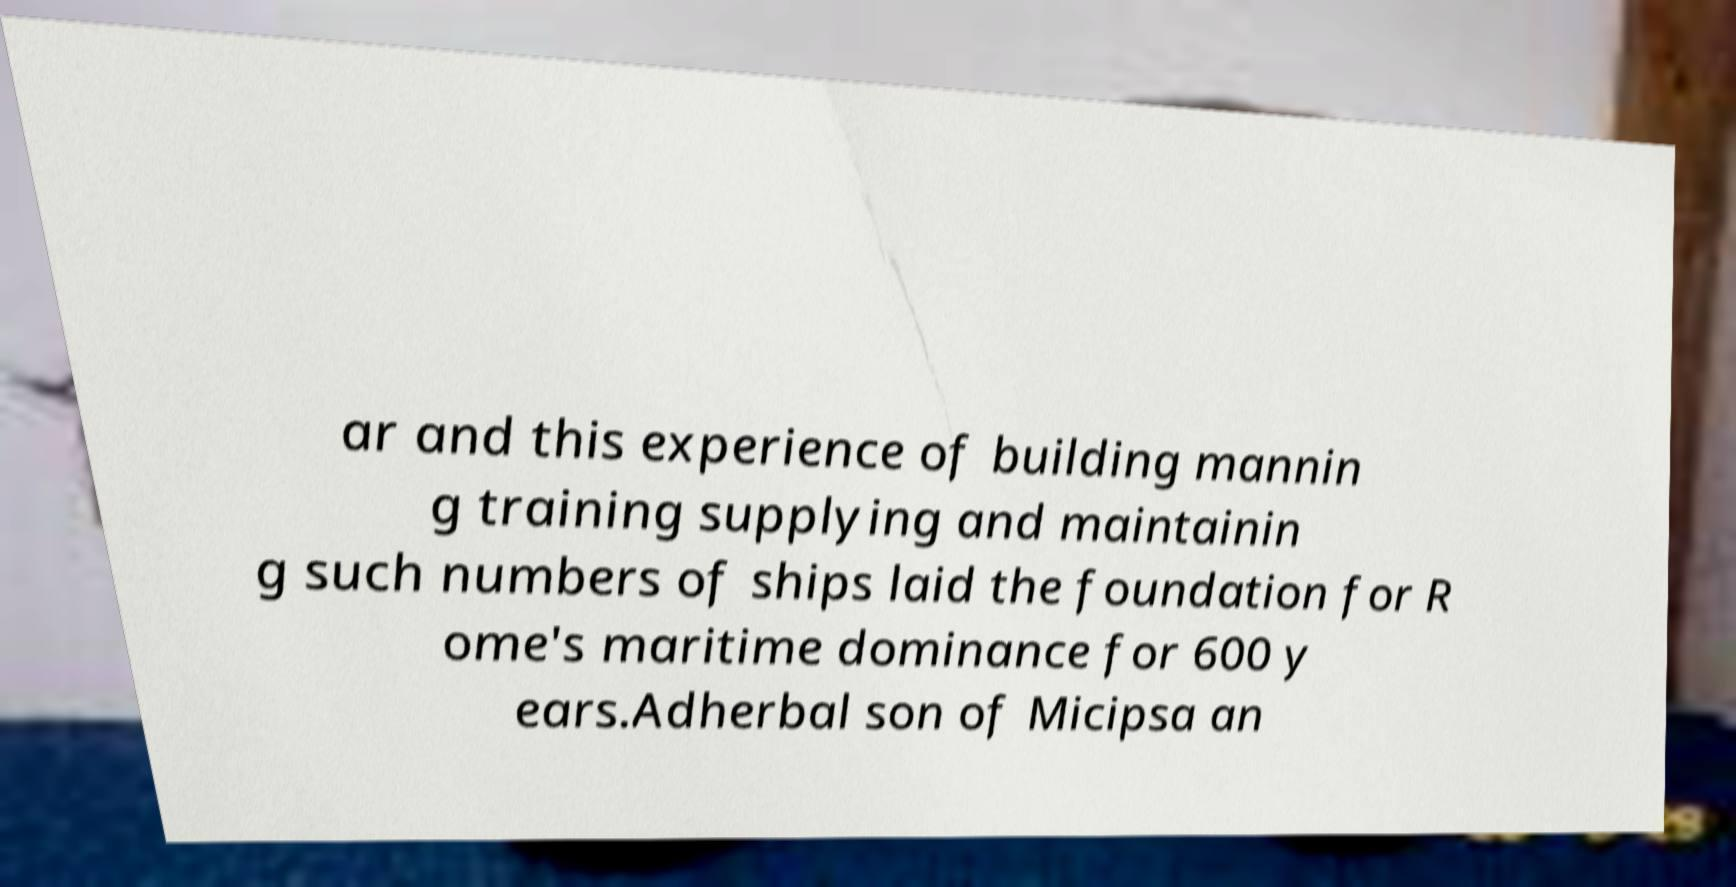Could you extract and type out the text from this image? ar and this experience of building mannin g training supplying and maintainin g such numbers of ships laid the foundation for R ome's maritime dominance for 600 y ears.Adherbal son of Micipsa an 